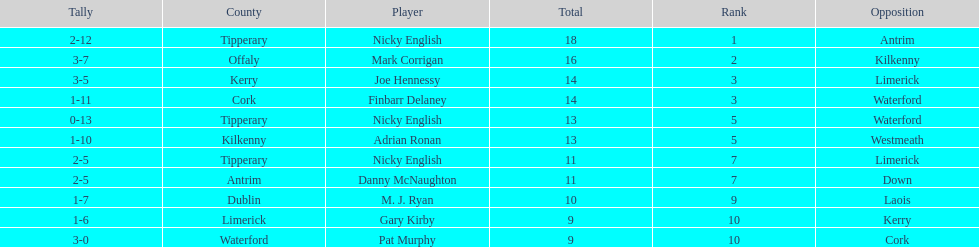What player got 10 total points in their game? M. J. Ryan. 